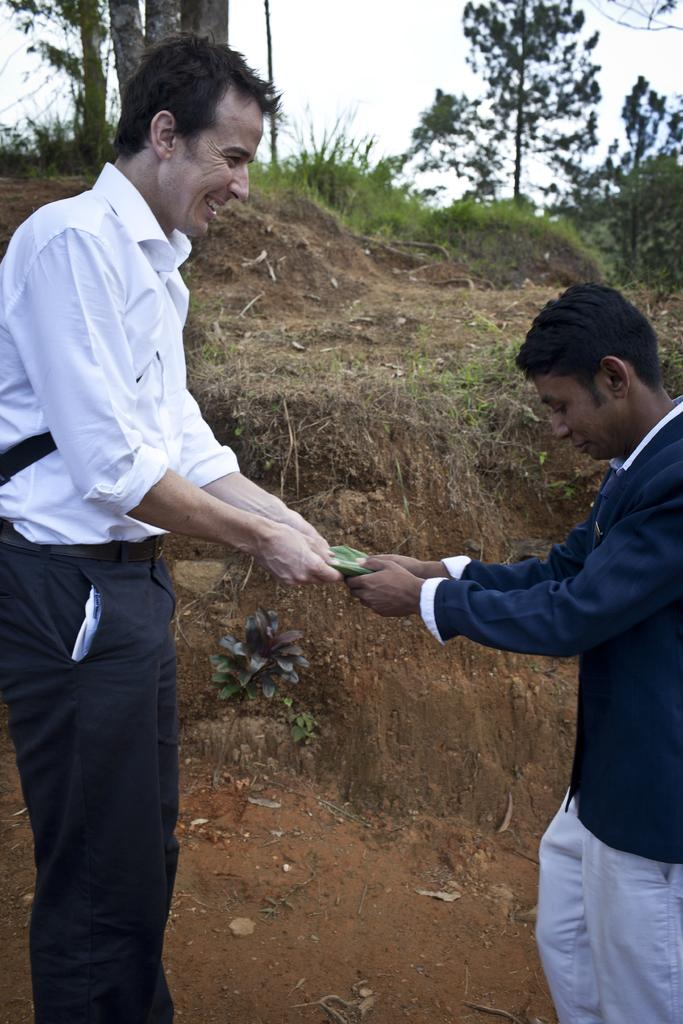How many people are in the image? There are two people in the image. What are the people doing in the image? The people are standing and holding an object. What type of vegetation is visible in the image? There is a plant, trees, and grass visible in the image. What can be seen in the background of the image? The sky is visible in the background of the image. What type of thrill can be seen in the image? There is no thrill present in the image; it features two people standing and holding an object. What type of lumber is being used by the people in the image? There is no lumber present in the image; the people are holding an unspecified object. 